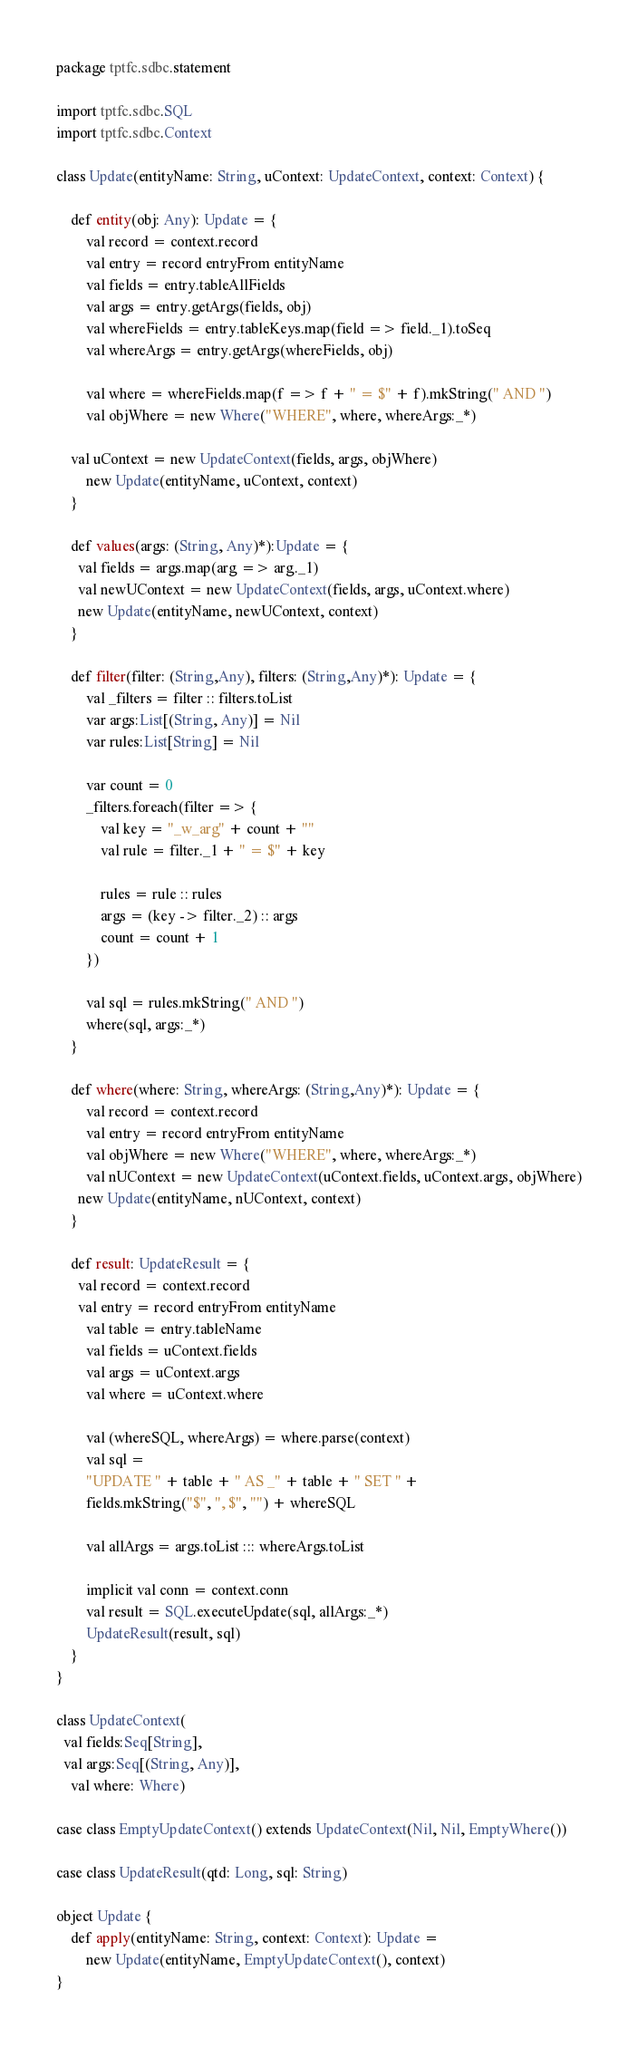Convert code to text. <code><loc_0><loc_0><loc_500><loc_500><_Scala_>package tptfc.sdbc.statement

import tptfc.sdbc.SQL
import tptfc.sdbc.Context

class Update(entityName: String, uContext: UpdateContext, context: Context) {

	def entity(obj: Any): Update = {
		val record = context.record
		val entry = record entryFrom entityName
		val fields = entry.tableAllFields
		val args = entry.getArgs(fields, obj)
		val whereFields = entry.tableKeys.map(field => field._1).toSeq
		val whereArgs = entry.getArgs(whereFields, obj)

		val where = whereFields.map(f => f + " = $" + f).mkString(" AND ")
		val objWhere = new Where("WHERE", where, whereArgs:_*)

    val uContext = new UpdateContext(fields, args, objWhere)
		new Update(entityName, uContext, context)
	}

	def values(args: (String, Any)*):Update = {
	  val fields = args.map(arg => arg._1)
	  val newUContext = new UpdateContext(fields, args, uContext.where)
	  new Update(entityName, newUContext, context)
	}

	def filter(filter: (String,Any), filters: (String,Any)*): Update = {
		val _filters = filter :: filters.toList
		var args:List[(String, Any)] = Nil
		var rules:List[String] = Nil

		var count = 0
		_filters.foreach(filter => {
			val key = "_w_arg" + count + ""
			val rule = filter._1 + " = $" + key

			rules = rule :: rules
			args = (key -> filter._2) :: args
			count = count + 1
		})

		val sql = rules.mkString(" AND ")
		where(sql, args:_*)
	}

	def where(where: String, whereArgs: (String,Any)*): Update = {
		val record = context.record
		val entry = record entryFrom entityName
		val objWhere = new Where("WHERE", where, whereArgs:_*)
		val nUContext = new UpdateContext(uContext.fields, uContext.args, objWhere)
	  new Update(entityName, nUContext, context)
	}

	def result: UpdateResult = {
	  val record = context.record
	  val entry = record entryFrom entityName
		val table = entry.tableName
		val fields = uContext.fields
		val args = uContext.args
		val where = uContext.where

		val (whereSQL, whereArgs) = where.parse(context)
		val sql =
		"UPDATE " + table + " AS _" + table + " SET " +
		fields.mkString("$", ", $", "") + whereSQL

		val allArgs = args.toList ::: whereArgs.toList

		implicit val conn = context.conn
		val result = SQL.executeUpdate(sql, allArgs:_*)
		UpdateResult(result, sql)
	}
}

class UpdateContext(
  val fields:Seq[String],
  val args:Seq[(String, Any)],
	val where: Where)

case class EmptyUpdateContext() extends UpdateContext(Nil, Nil, EmptyWhere())

case class UpdateResult(qtd: Long, sql: String)

object Update {
	def apply(entityName: String, context: Context): Update =
		new Update(entityName, EmptyUpdateContext(), context)
}
</code> 